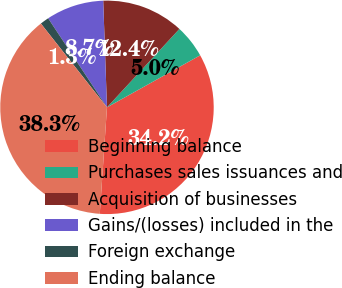Convert chart. <chart><loc_0><loc_0><loc_500><loc_500><pie_chart><fcel>Beginning balance<fcel>Purchases sales issuances and<fcel>Acquisition of businesses<fcel>Gains/(losses) included in the<fcel>Foreign exchange<fcel>Ending balance<nl><fcel>34.18%<fcel>5.03%<fcel>12.43%<fcel>8.73%<fcel>1.34%<fcel>38.3%<nl></chart> 